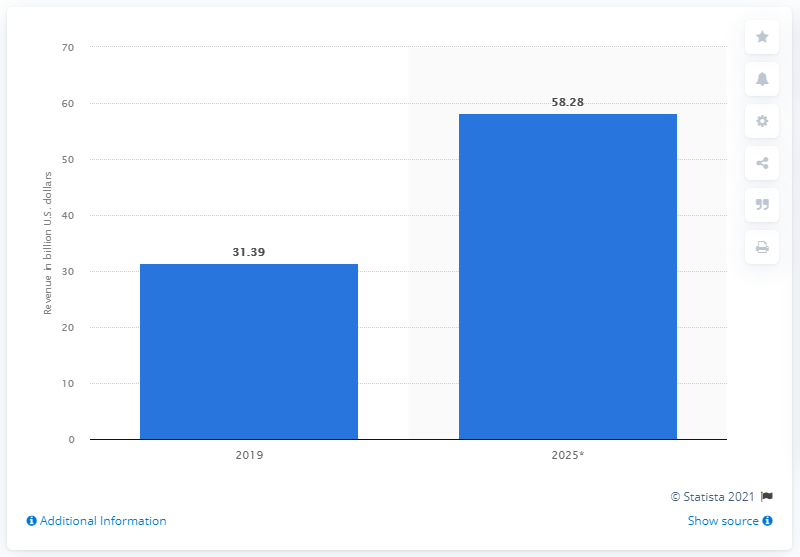Identify some key points in this picture. In 2019, the global revenue from the colocation data center market was approximately $31.39 billion. 